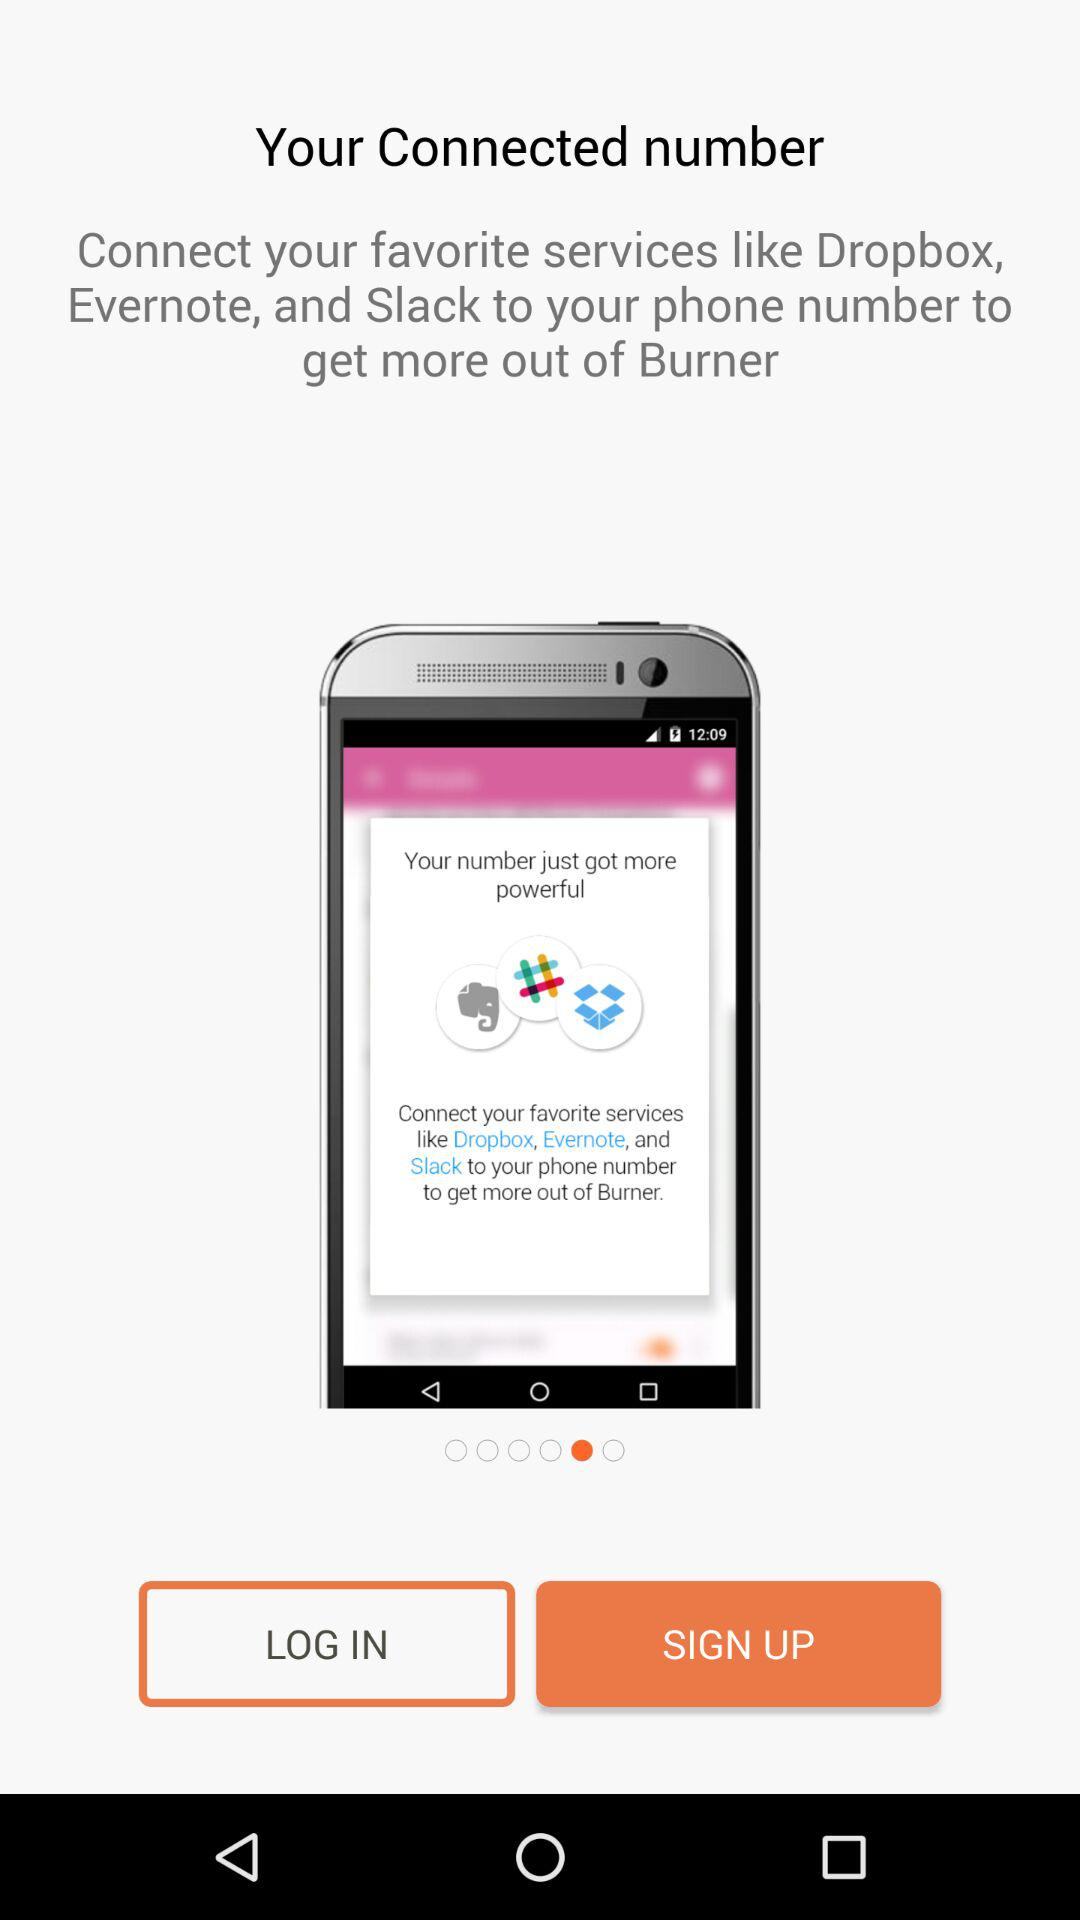How many services can you connect to your phone number?
Answer the question using a single word or phrase. 3 